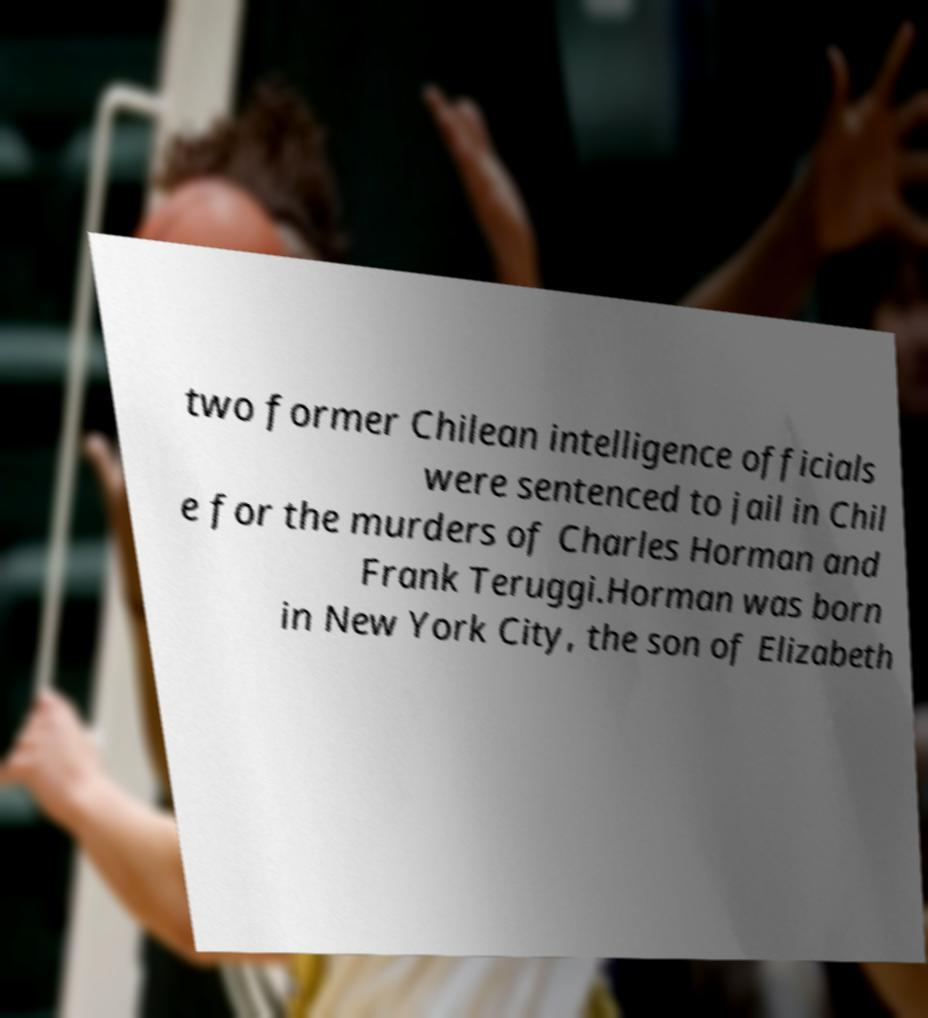For documentation purposes, I need the text within this image transcribed. Could you provide that? two former Chilean intelligence officials were sentenced to jail in Chil e for the murders of Charles Horman and Frank Teruggi.Horman was born in New York City, the son of Elizabeth 